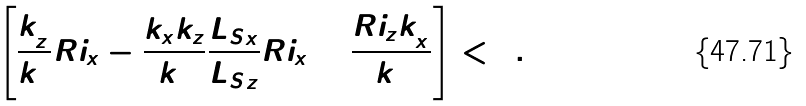Convert formula to latex. <formula><loc_0><loc_0><loc_500><loc_500>\left [ \frac { k _ { z } ^ { 2 } } { k ^ { 2 } } R i _ { x } - \frac { k _ { x } k _ { z } } { k ^ { 2 } } \frac { { L _ { S } } _ { x } } { { L _ { S } } _ { z } } R i _ { x } + \frac { R i _ { z } k _ { x } ^ { 2 } } { k ^ { 2 } } \right ] < 0 .</formula> 